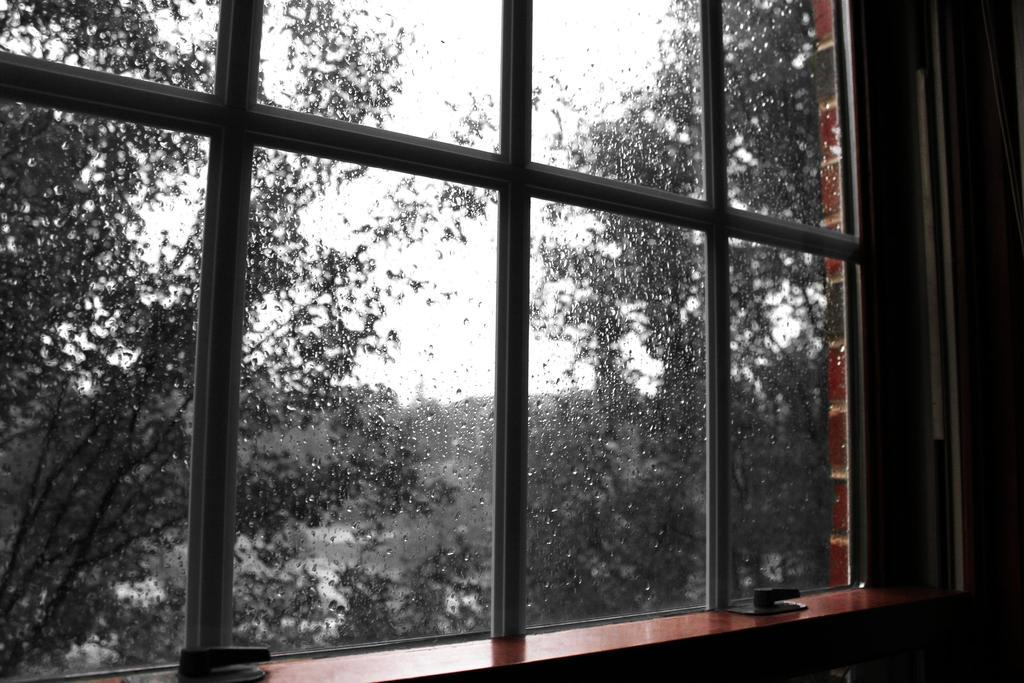What type of structure is present in the image? There is a wall in the image. Is there any opening in the wall? Yes, there is a window in the image. What can be seen through the window? Trees are visible through the window. How many cars are parked next to the wall in the image? There are no cars present in the image; it only features a wall and a window with trees visible through it. 